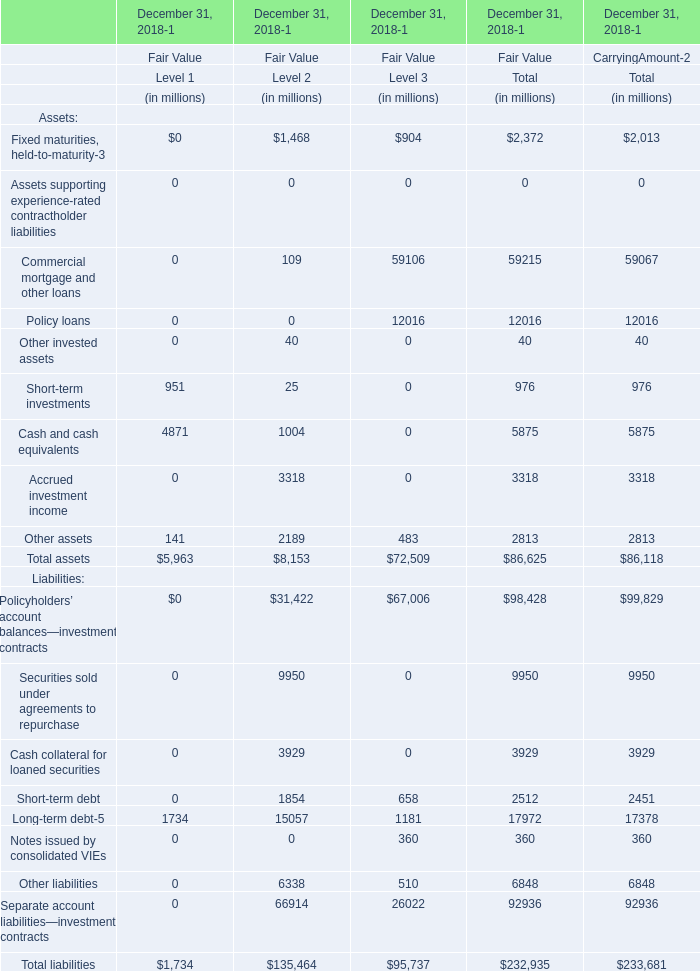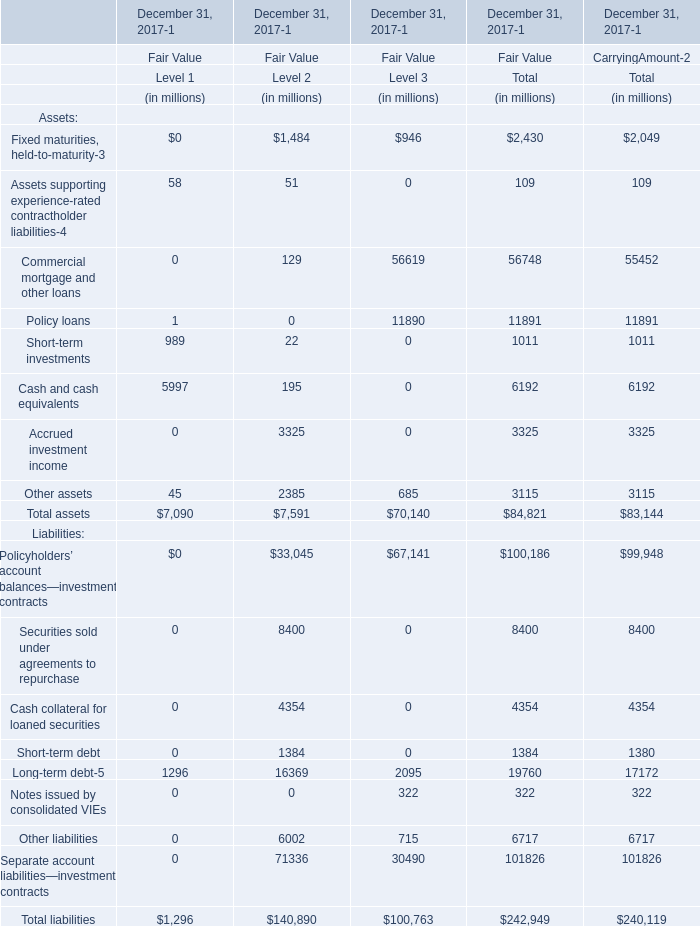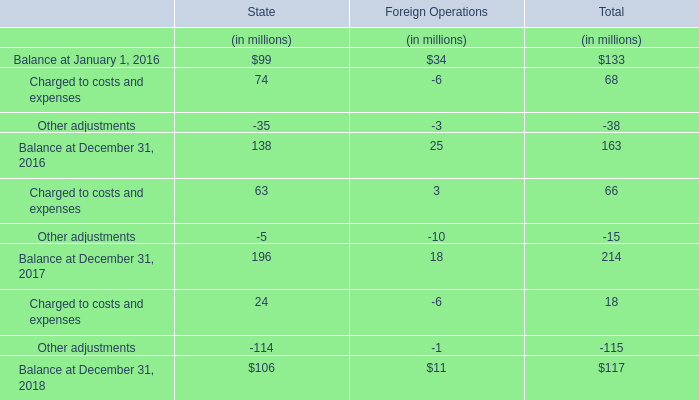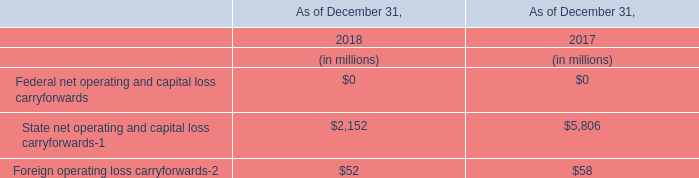What do all Level 1 sum up in 2017 for Fair Value for December 31, 2017-1, excluding Assets supporting experience-rated contractholder liabilities-4 and Short-term investments? (in million) 
Computations: (((5997 + 45) + 1296) + 1)
Answer: 7339.0. 